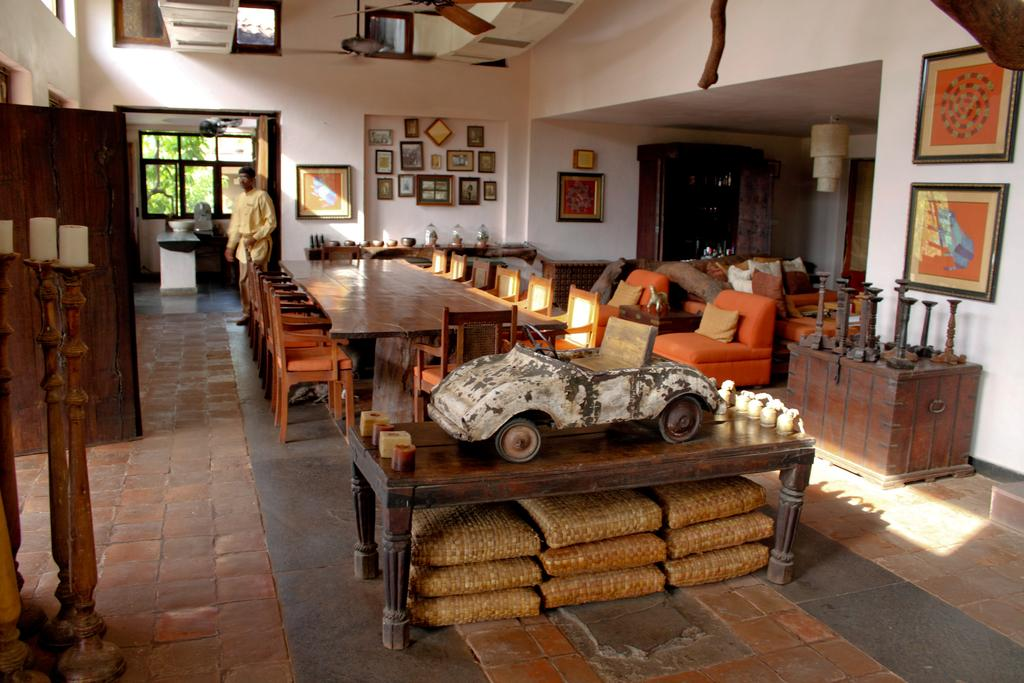What type of furniture is present in the image? There is a table and chairs in the image. What is the man in the image doing? The man is standing in the image. What can be seen on the wall in the image? There are photo frames on the wall. What object is on the table in the image? There is a toy car on the table. How many people are running in the image? There are no people running in the image. Is the man in the image the father of the children in the photo frames? We cannot determine the man's relationship to the people in the photo frames from the image alone. 